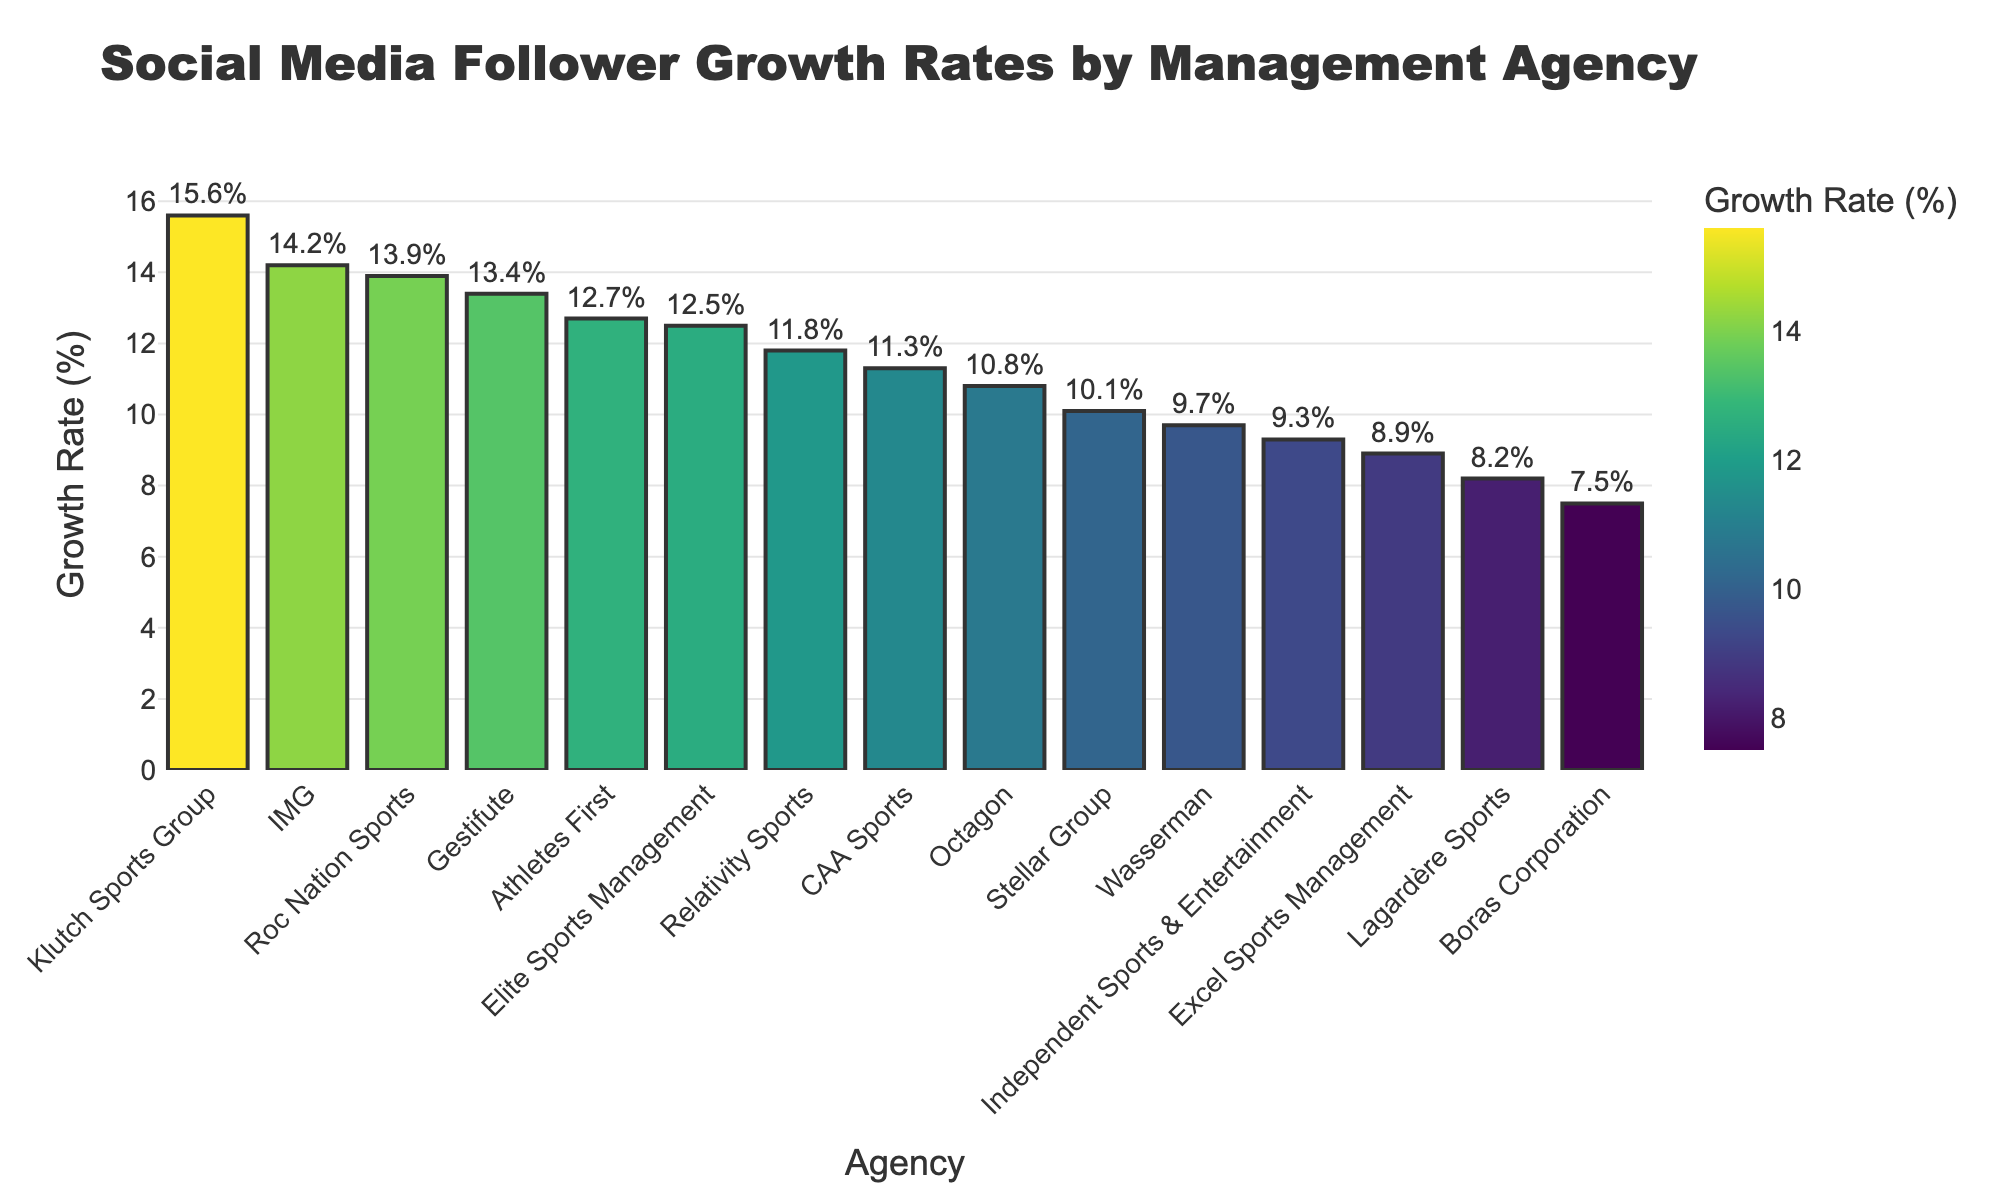Which management agency has the highest social media follower growth rate? The bar chart shows the growth rates for different agencies, and the highest bar corresponds to Klutch Sports Group with a growth rate of 15.6%.
Answer: Klutch Sports Group Which management agency has the lowest social media follower growth rate? By observing the shortest bar on the chart, Excel Sports Management has the lowest growth rate at 8.9%.
Answer: Excel Sports Management What is the difference in growth rates between the highest and lowest agencies? The highest growth rate is Klutch Sports Group (15.6%) and the lowest is Excel Sports Management (8.9%). Subtracting these gives 15.6 - 8.9 = 6.7%.
Answer: 6.7% Which agencies have growth rates above 13%? The agencies with growth rates above 13% are IMG (14.2%), Klutch Sports Group (15.6%), Roc Nation Sports (13.9%), and Gestifute (13.4%).
Answer: IMG, Klutch Sports Group, Roc Nation Sports, Gestifute What is the sum of the growth rates for Octagon and CAA Sports? Octagon has a growth rate of 10.8% and CAA Sports has 11.3%. Adding these gives 10.8 + 11.3 = 22.1%.
Answer: 22.1% Are there more agencies with growth rates above or below 10%? Count the agencies with growth rates above 10% (Elite Sports Management, Octagon, IMG, CAA Sports, Klutch Sports Group, Roc Nation Sports, Stellar Group, Gestifute, Relativity Sports, Athletes First). There are 10 such agencies. Count the agencies below 10% (Wasserman, Excel Sports Management, Boras Corporation, Independent Sports & Entertainment, Lagardère Sports). There are 5 such agencies. So, there are more agencies with growth rates above 10%.
Answer: Above Which agency has a growth rate closest to 12%? By comparing the growth rates close to 12%, Athletes First has a growth rate of 12.7%, which is the closest to 12%.
Answer: Athletes First What is the average growth rate of all agencies? Sum all the growth rates: 12.5 + 10.8 + 14.2 + 9.7 + 11.3 + 15.6 + 13.9 + 8.9 + 7.5 + 10.1 + 13.4 + 9.3 + 8.2 + 11.8 + 12.7 = 170.9. There are 15 agencies, so the average is 170.9 / 15 ≈ 11.39%.
Answer: 11.39% Which management agency has a growth rate visually indicated by the darkest color? The darkest color on the bar chart typically corresponds to the highest growth rate, which is Klutch Sports Group with 15.6%.
Answer: Klutch Sports Group 